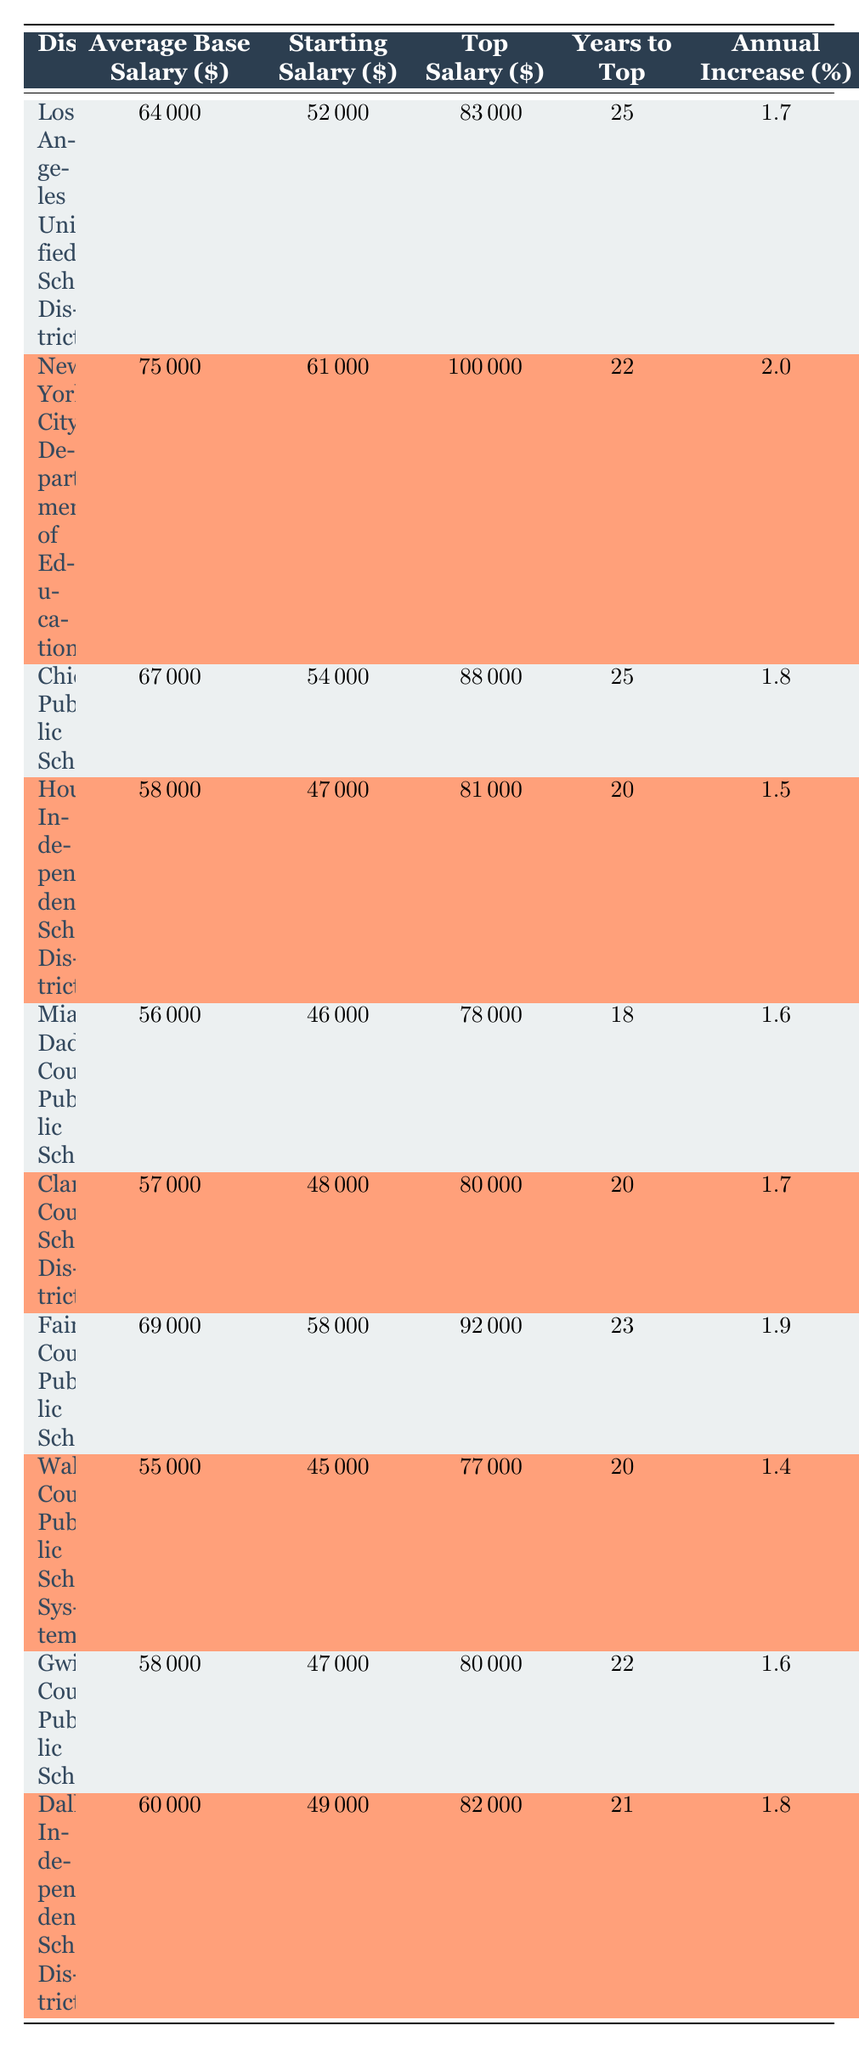What is the average base salary for the New York City Department of Education? The table shows the average base salary for the New York City Department of Education listed as 75000.
Answer: 75000 Which district has the highest top salary? The table indicates that the New York City Department of Education has the highest top salary of 100000 among all districts.
Answer: 100000 How many years does it take to reach the top salary in the Miami-Dade County Public Schools? According to the table, the Miami-Dade County Public Schools require 18 years to reach the top salary.
Answer: 18 What is the difference in starting salary between the Los Angeles Unified School District and the Chicago Public Schools? The starting salary for Los Angeles Unified School District is 52000, and for Chicago Public Schools, it is 54000. The difference is 54000 - 52000 = 2000.
Answer: 2000 Is the average base salary for Wake County Public School System greater than 60000? The average base salary for Wake County Public School System is 55000, which is less than 60000. Thus, the answer is no.
Answer: No What is the annual salary increase percentage for the Fairfax County Public Schools? The table shows that the annual salary increase percentage for Fairfax County Public Schools is 1.9.
Answer: 1.9 If you average the top salaries of all the districts, what would it be? The top salaries are 83000, 100000, 88000, 81000, 78000, 80000, 92000, 77000, 80000, and 82000. The sum is 832000 and there are 10 districts, so the average is 832000/10 = 83200.
Answer: 83200 Which district has the lowest average base salary? The table shows that the Houston Independent School District has the lowest average base salary of 58000 compared to other districts.
Answer: 58000 How much does the average base salary of districts in Florida compare to that of California? The average base salary in Florida (Miami-Dade County Public Schools) is 56000, while in California (Los Angeles Unified School District) it is 64000. The difference is 64000 - 56000 = 8000, indicating that California pays more.
Answer: 8000 